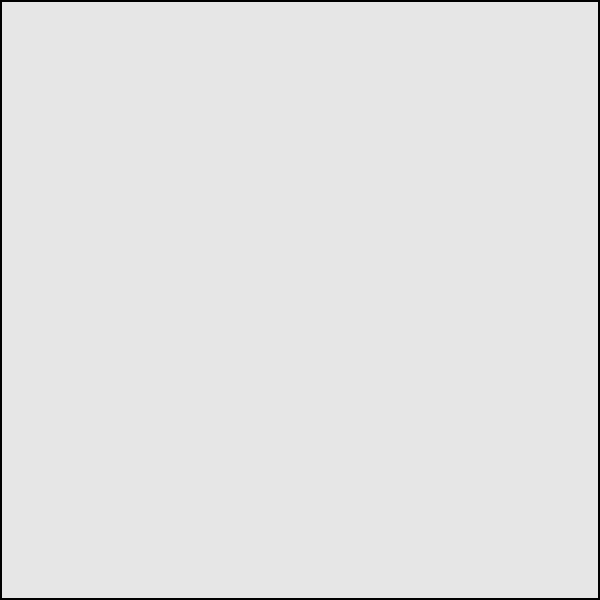As a gonzo journalist covering a controversial political rally, you've managed to obtain an aerial photograph of the event. The organizers claim 10,000 people attended, but you suspect the numbers are inflated. Given that the photographed area is roughly 50m x 50m and assuming an average personal space of 0.5m², estimate the actual crowd size. How many attendees were likely present? To estimate the crowd size, we'll follow these gonzo-inspired steps:

1. Calculate the total area:
   Area = 50m × 50m = 2500m²

2. Consider the average personal space:
   Each person occupies approximately 0.5m²

3. Calculate the maximum capacity:
   Max capacity = Total area ÷ Personal space
   $$ \text{Max capacity} = \frac{2500\text{m}^2}{0.5\text{m}^2/\text{person}} = 5000 \text{ people} $$

4. Account for empty spaces and movement:
   Realistically, the crowd won't be at maximum capacity. Let's assume 80% efficiency:
   $$ \text{Estimated attendance} = 5000 \times 0.8 = 4000 \text{ people} $$

5. Round to the nearest hundred for a more believable estimate:
   $$ \text{Final estimate} \approx 4000 \text{ people} $$

As Joe Bageant might say, "The truth lies in the gritty details, not the polished numbers fed to the masses." Our estimate of 4000 people is far cry from the organizers' claim of 10,000, exposing potential inflation in their reported figures.
Answer: Approximately 4000 people 